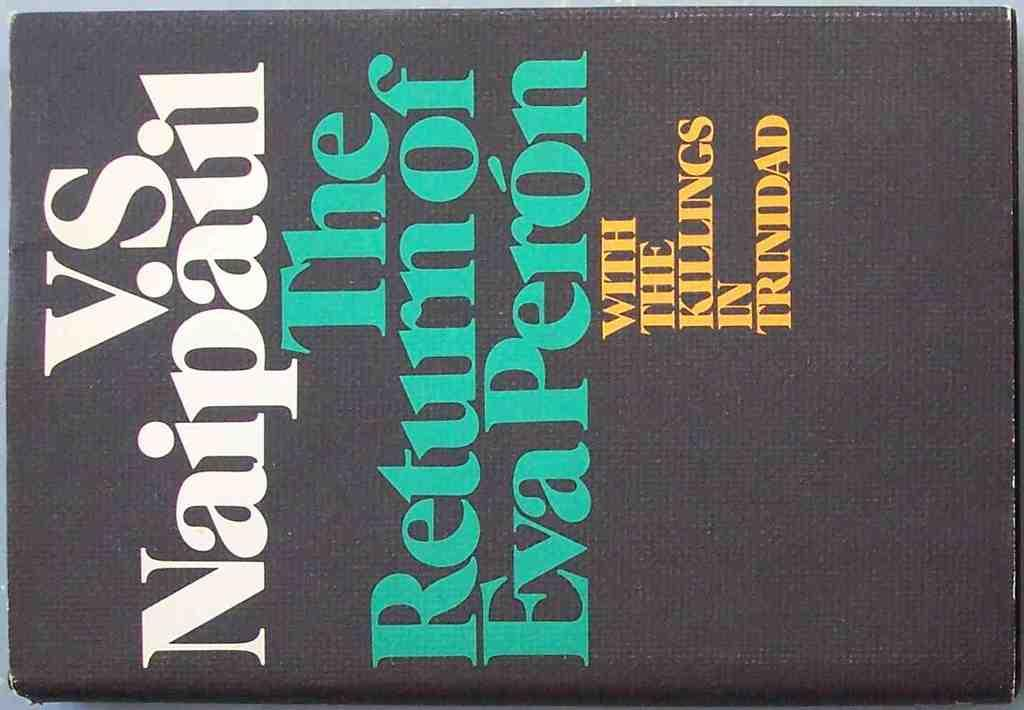<image>
Write a terse but informative summary of the picture. Book saying V.S. Naipaul The Return of Eva Peron with the Killings of Trinidad. 